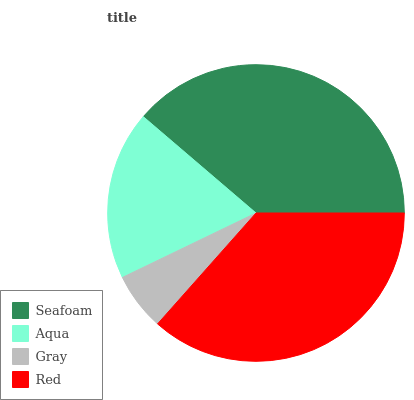Is Gray the minimum?
Answer yes or no. Yes. Is Seafoam the maximum?
Answer yes or no. Yes. Is Aqua the minimum?
Answer yes or no. No. Is Aqua the maximum?
Answer yes or no. No. Is Seafoam greater than Aqua?
Answer yes or no. Yes. Is Aqua less than Seafoam?
Answer yes or no. Yes. Is Aqua greater than Seafoam?
Answer yes or no. No. Is Seafoam less than Aqua?
Answer yes or no. No. Is Red the high median?
Answer yes or no. Yes. Is Aqua the low median?
Answer yes or no. Yes. Is Seafoam the high median?
Answer yes or no. No. Is Red the low median?
Answer yes or no. No. 